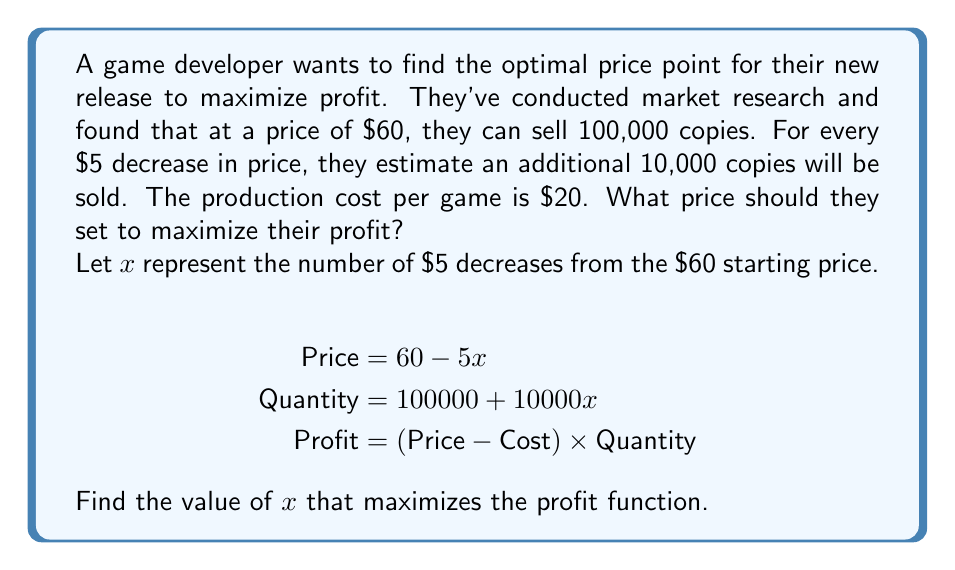Provide a solution to this math problem. Let's approach this step-by-step:

1) First, let's write out the profit function:
   $$\text{Profit} = (60 - 5x - 20)(100000 + 10000x)$$

2) Expand this equation:
   $$\text{Profit} = (40 - 5x)(100000 + 10000x)$$
   $$= 4000000 + 400000x - 500000x - 50000x^2$$
   $$= 4000000 - 100000x - 50000x^2$$

3) To find the maximum profit, we need to find where the derivative of this function equals zero:
   $$\frac{d}{dx}(\text{Profit}) = -100000 - 100000x$$

4) Set this equal to zero and solve for x:
   $$-100000 - 100000x = 0$$
   $$-100000x = 100000$$
   $$x = -1$$

5) The second derivative is negative $(-100000)$, confirming this is a maximum.

6) Since $x$ represents the number of $5 decreases, and we can't have a negative number of decreases, the closest we can get to the theoretical maximum is $x = 0$.

7) Therefore, the optimal price is the original price of $60.

8) We can verify this by calculating profits at $60 and $55:
   At $60: $(60 - 20) * 100000 = $4,000,000
   At $55: $(55 - 20) * 110000 = $3,850,000
Answer: $60 